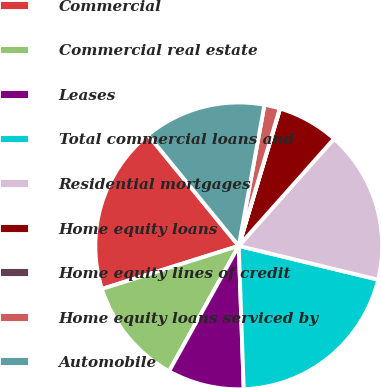<chart> <loc_0><loc_0><loc_500><loc_500><pie_chart><fcel>Commercial<fcel>Commercial real estate<fcel>Leases<fcel>Total commercial loans and<fcel>Residential mortgages<fcel>Home equity loans<fcel>Home equity lines of credit<fcel>Home equity loans serviced by<fcel>Automobile<nl><fcel>18.94%<fcel>12.07%<fcel>8.63%<fcel>20.66%<fcel>17.22%<fcel>6.91%<fcel>0.04%<fcel>1.75%<fcel>13.78%<nl></chart> 